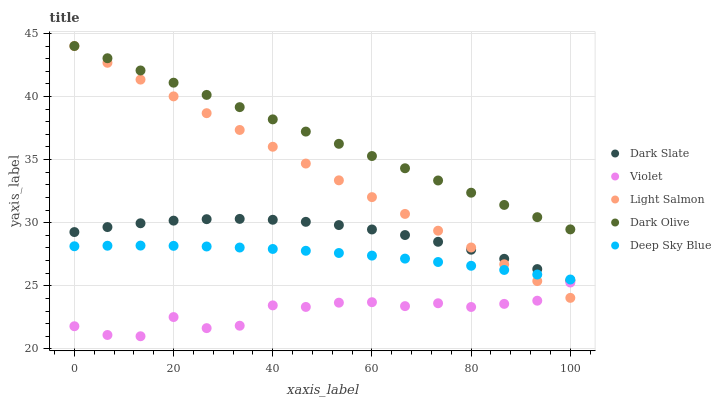Does Violet have the minimum area under the curve?
Answer yes or no. Yes. Does Dark Olive have the maximum area under the curve?
Answer yes or no. Yes. Does Light Salmon have the minimum area under the curve?
Answer yes or no. No. Does Light Salmon have the maximum area under the curve?
Answer yes or no. No. Is Light Salmon the smoothest?
Answer yes or no. Yes. Is Violet the roughest?
Answer yes or no. Yes. Is Dark Olive the smoothest?
Answer yes or no. No. Is Dark Olive the roughest?
Answer yes or no. No. Does Violet have the lowest value?
Answer yes or no. Yes. Does Light Salmon have the lowest value?
Answer yes or no. No. Does Dark Olive have the highest value?
Answer yes or no. Yes. Does Deep Sky Blue have the highest value?
Answer yes or no. No. Is Violet less than Dark Olive?
Answer yes or no. Yes. Is Dark Olive greater than Deep Sky Blue?
Answer yes or no. Yes. Does Light Salmon intersect Dark Olive?
Answer yes or no. Yes. Is Light Salmon less than Dark Olive?
Answer yes or no. No. Is Light Salmon greater than Dark Olive?
Answer yes or no. No. Does Violet intersect Dark Olive?
Answer yes or no. No. 